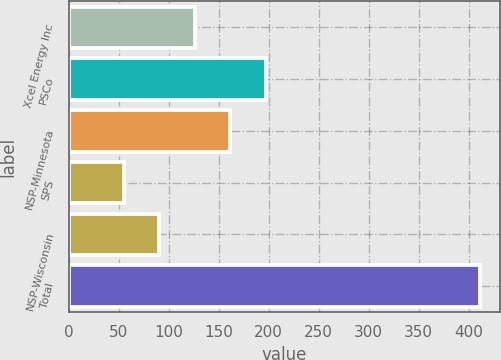<chart> <loc_0><loc_0><loc_500><loc_500><bar_chart><fcel>Xcel Energy Inc<fcel>PSCo<fcel>NSP-Minnesota<fcel>SPS<fcel>NSP-Wisconsin<fcel>Total<nl><fcel>126.2<fcel>197.4<fcel>161.8<fcel>55<fcel>90.6<fcel>411<nl></chart> 